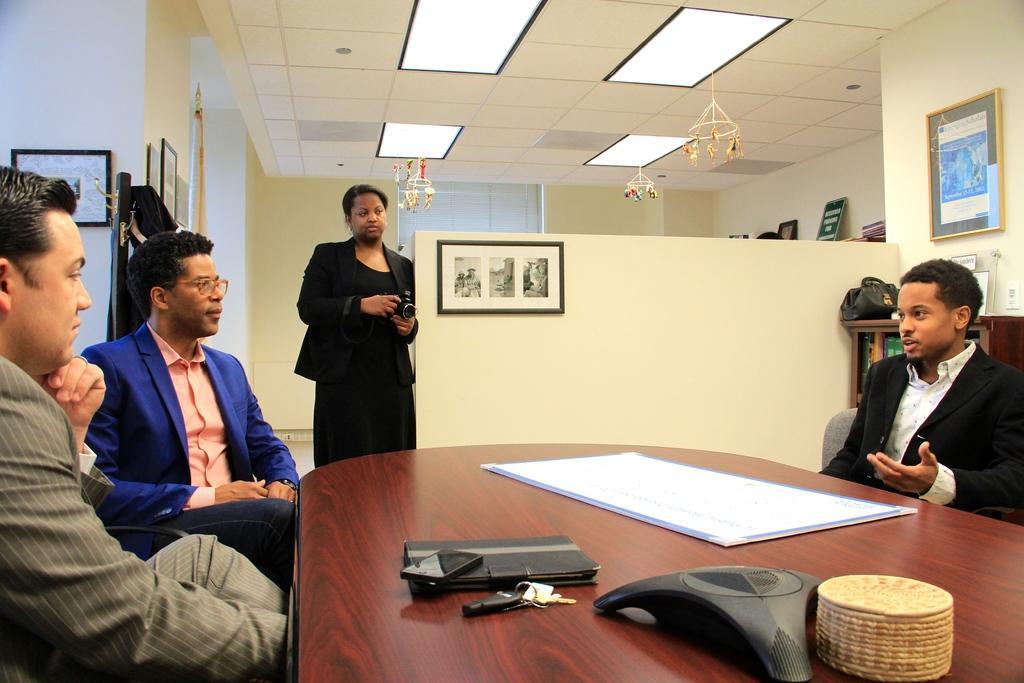How would you summarize this image in a sentence or two? In this image I can see three people sitting in-front of the table. On the table there is a keys,mobile,wallet and the paper. Among them one person is standing with the camera. To the right there is a bag and some objects on the cupboard. In the back ground there are frames attached to the wall,lights and the decorative hangings. 